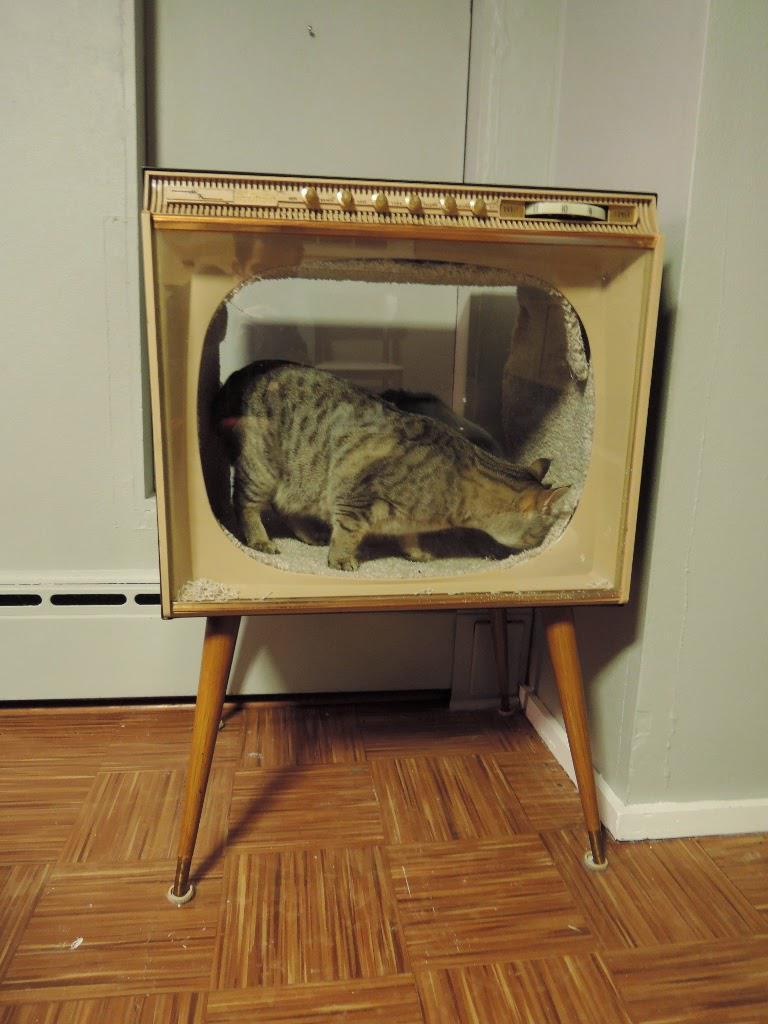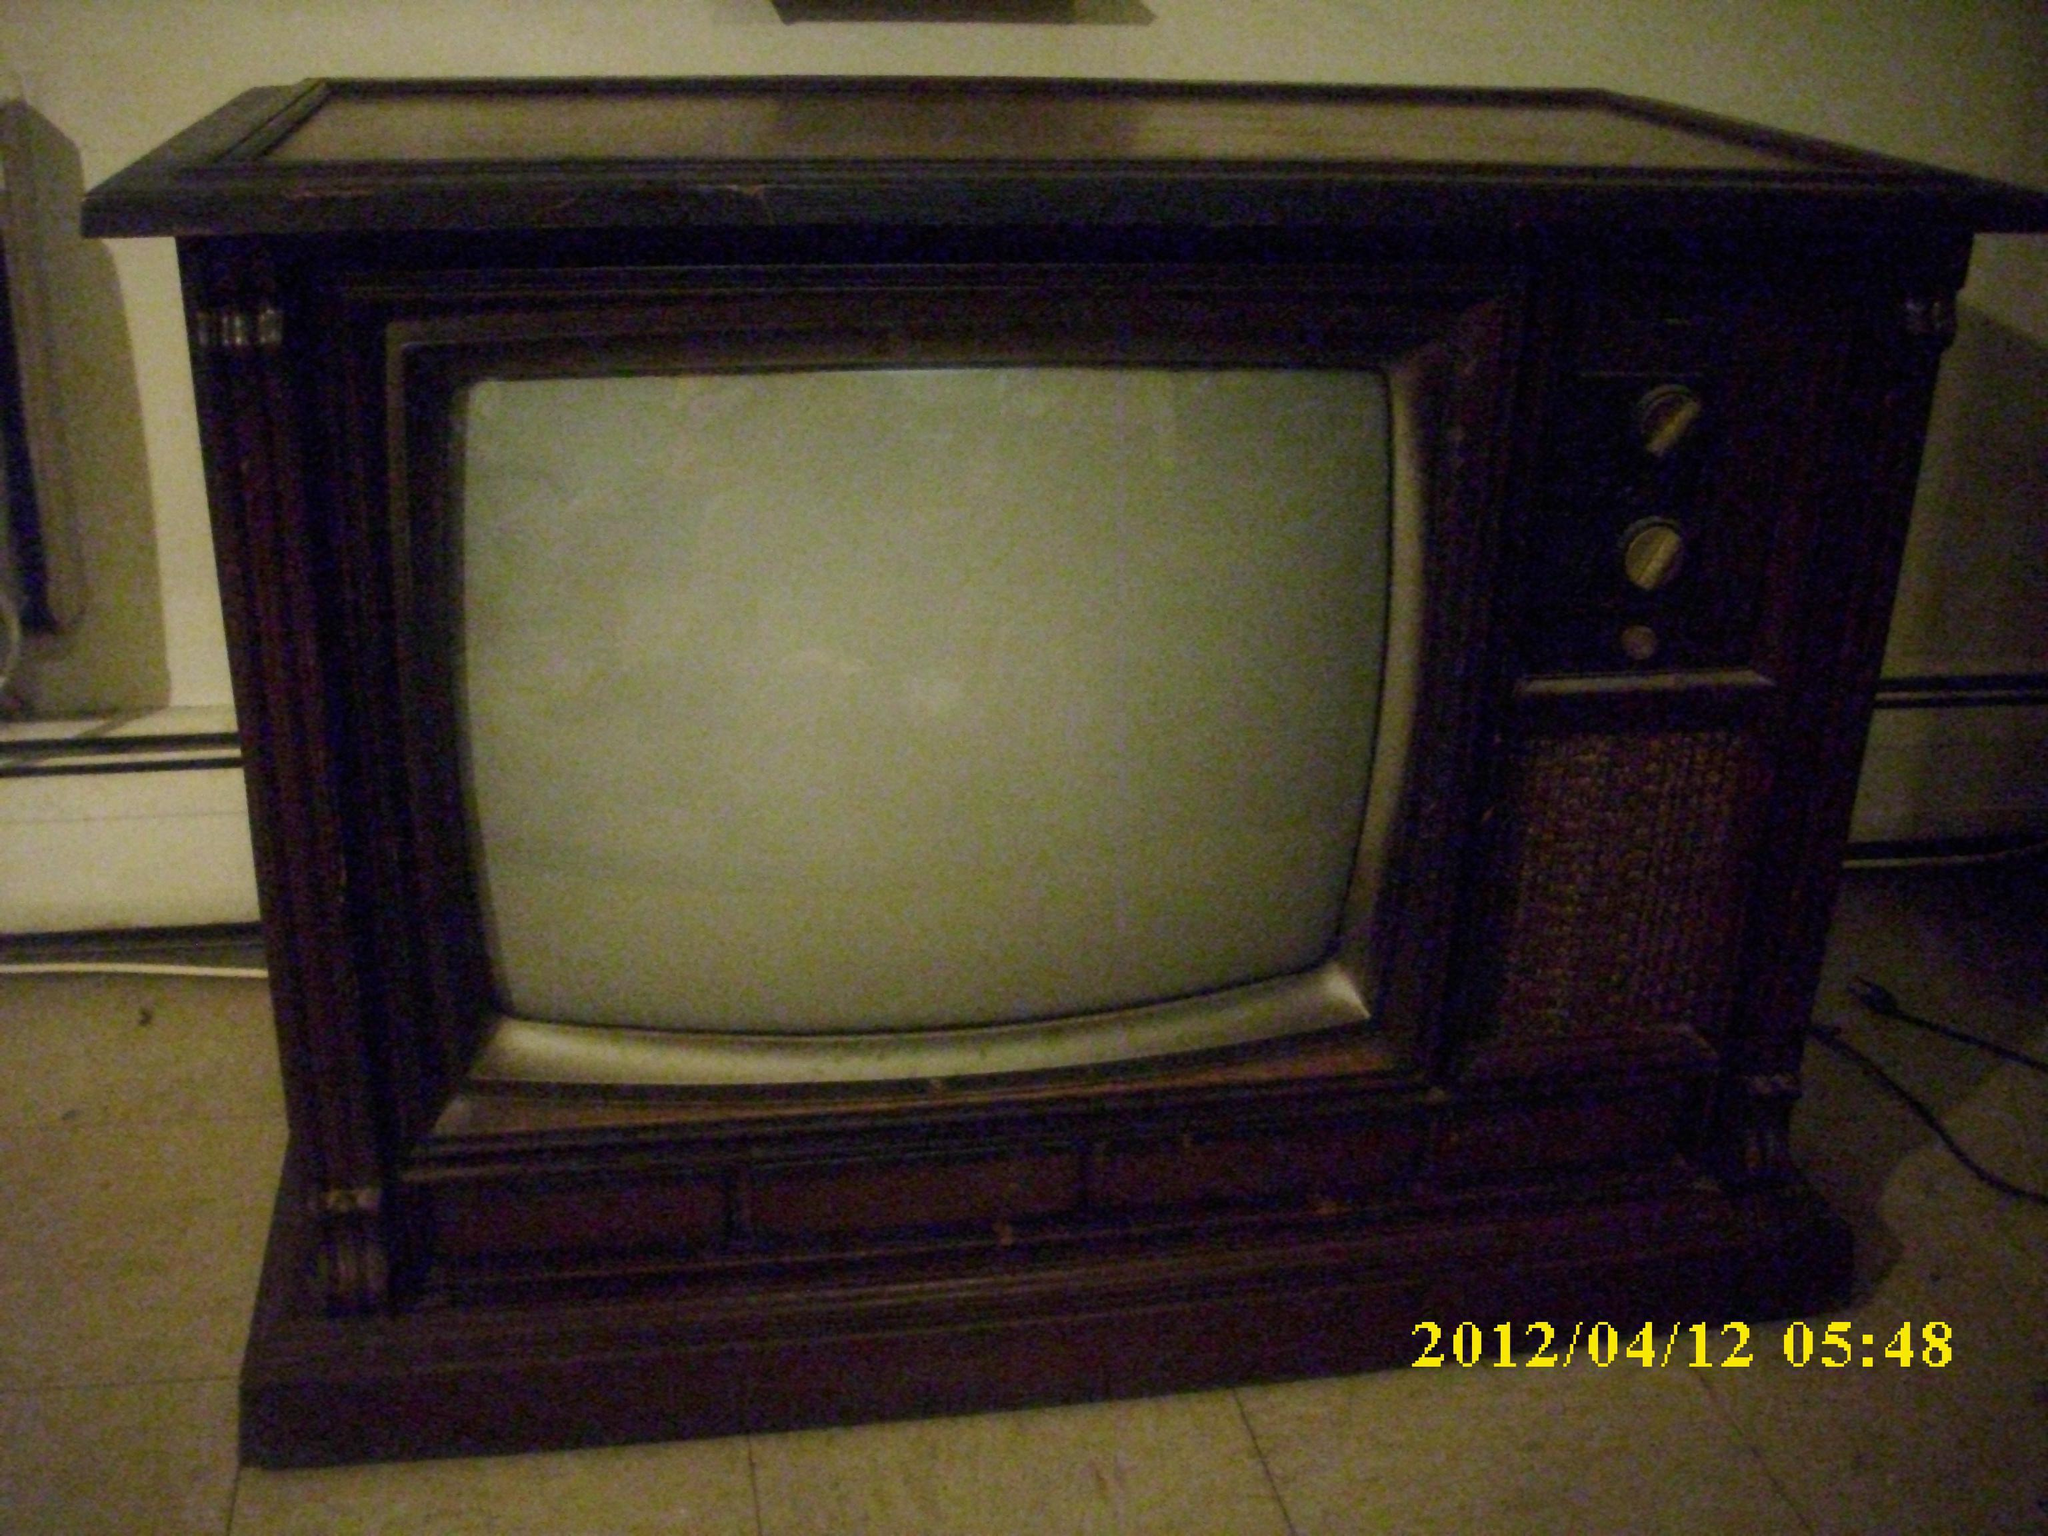The first image is the image on the left, the second image is the image on the right. Evaluate the accuracy of this statement regarding the images: "There are two tvs, and one of them has had its screen removed.". Is it true? Answer yes or no. Yes. The first image is the image on the left, the second image is the image on the right. For the images shown, is this caption "At least one animal is inside a hollowed out antique television set." true? Answer yes or no. Yes. 